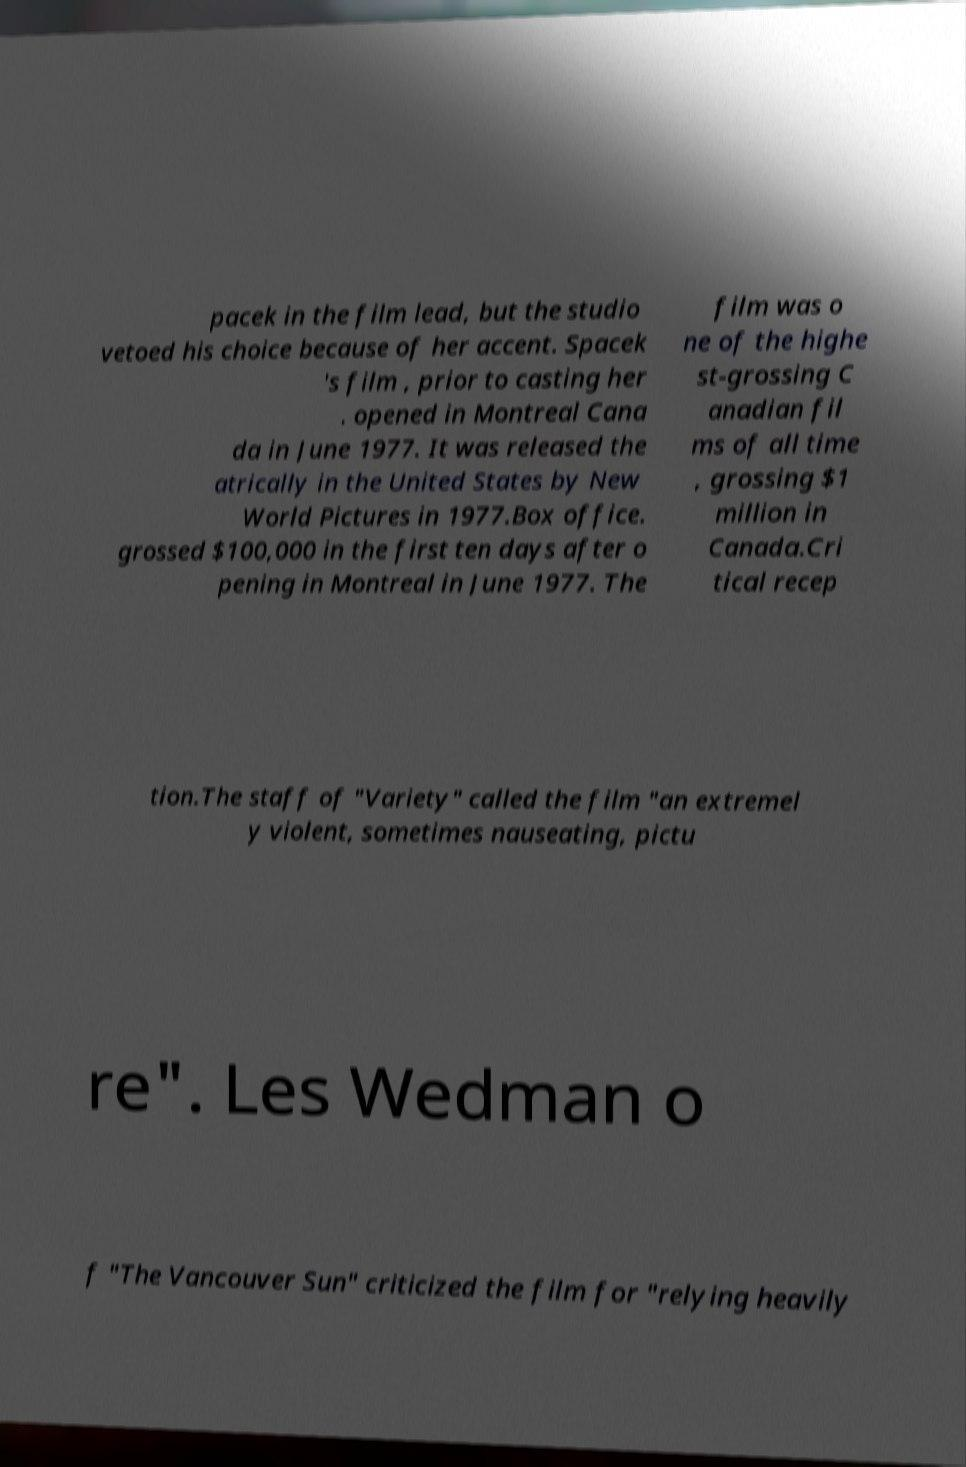Can you accurately transcribe the text from the provided image for me? pacek in the film lead, but the studio vetoed his choice because of her accent. Spacek 's film , prior to casting her . opened in Montreal Cana da in June 1977. It was released the atrically in the United States by New World Pictures in 1977.Box office. grossed $100,000 in the first ten days after o pening in Montreal in June 1977. The film was o ne of the highe st-grossing C anadian fil ms of all time , grossing $1 million in Canada.Cri tical recep tion.The staff of "Variety" called the film "an extremel y violent, sometimes nauseating, pictu re". Les Wedman o f "The Vancouver Sun" criticized the film for "relying heavily 